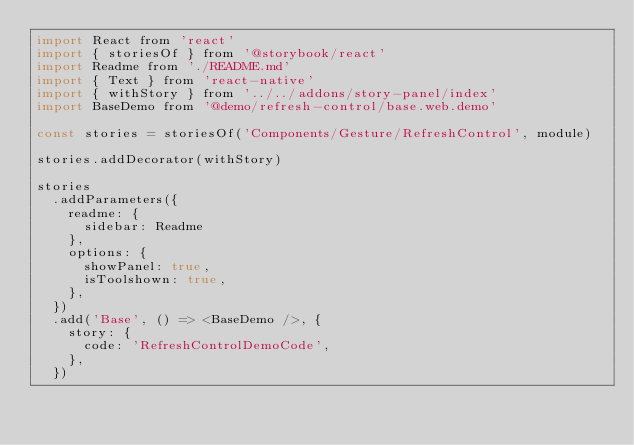Convert code to text. <code><loc_0><loc_0><loc_500><loc_500><_JavaScript_>import React from 'react'
import { storiesOf } from '@storybook/react'
import Readme from './README.md'
import { Text } from 'react-native'
import { withStory } from '../../addons/story-panel/index'
import BaseDemo from '@demo/refresh-control/base.web.demo'

const stories = storiesOf('Components/Gesture/RefreshControl', module)

stories.addDecorator(withStory)

stories
  .addParameters({
    readme: {
      sidebar: Readme
    },
    options: {
      showPanel: true,
      isToolshown: true,
    },
  })
  .add('Base', () => <BaseDemo />, {
    story: {
      code: 'RefreshControlDemoCode',
    },
  })
</code> 